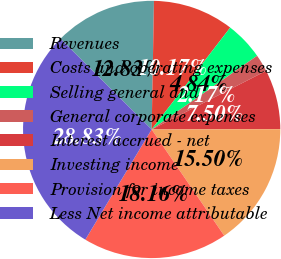<chart> <loc_0><loc_0><loc_500><loc_500><pie_chart><fcel>Revenues<fcel>Costs and operating expenses<fcel>Selling general and<fcel>General corporate expenses<fcel>Interest accrued - net<fcel>Investing income<fcel>Provision for income taxes<fcel>Less Net income attributable<nl><fcel>12.83%<fcel>10.17%<fcel>4.84%<fcel>2.17%<fcel>7.5%<fcel>15.5%<fcel>18.16%<fcel>28.83%<nl></chart> 